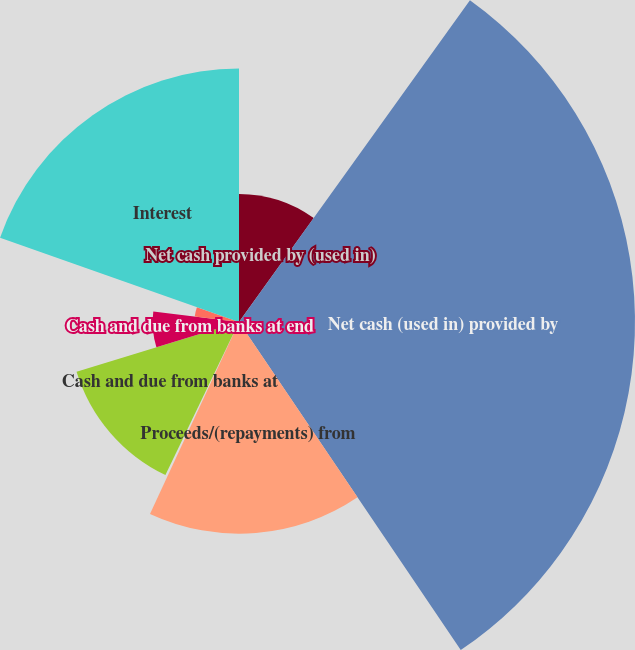Convert chart to OTSL. <chart><loc_0><loc_0><loc_500><loc_500><pie_chart><fcel>Net cash provided by (used in)<fcel>Net cash (used in) provided by<fcel>Proceeds/(repayments) from<fcel>Net (decrease) increase in<fcel>Cash and due from banks at<fcel>Cash and due from banks at end<fcel>Income taxes<fcel>Interest<nl><fcel>9.91%<fcel>30.63%<fcel>16.37%<fcel>0.22%<fcel>13.14%<fcel>6.68%<fcel>3.45%<fcel>19.6%<nl></chart> 